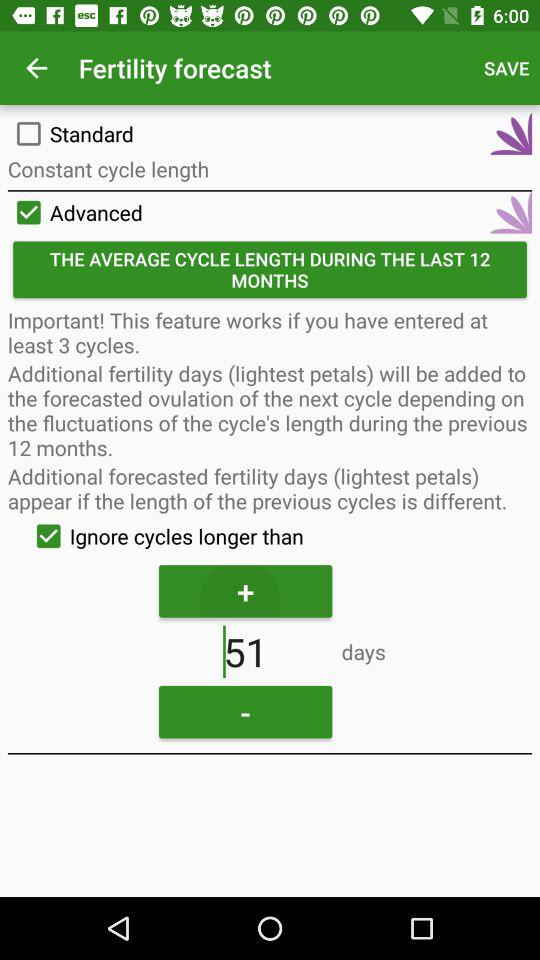What is the status of "Advanced"? The status is "on". 